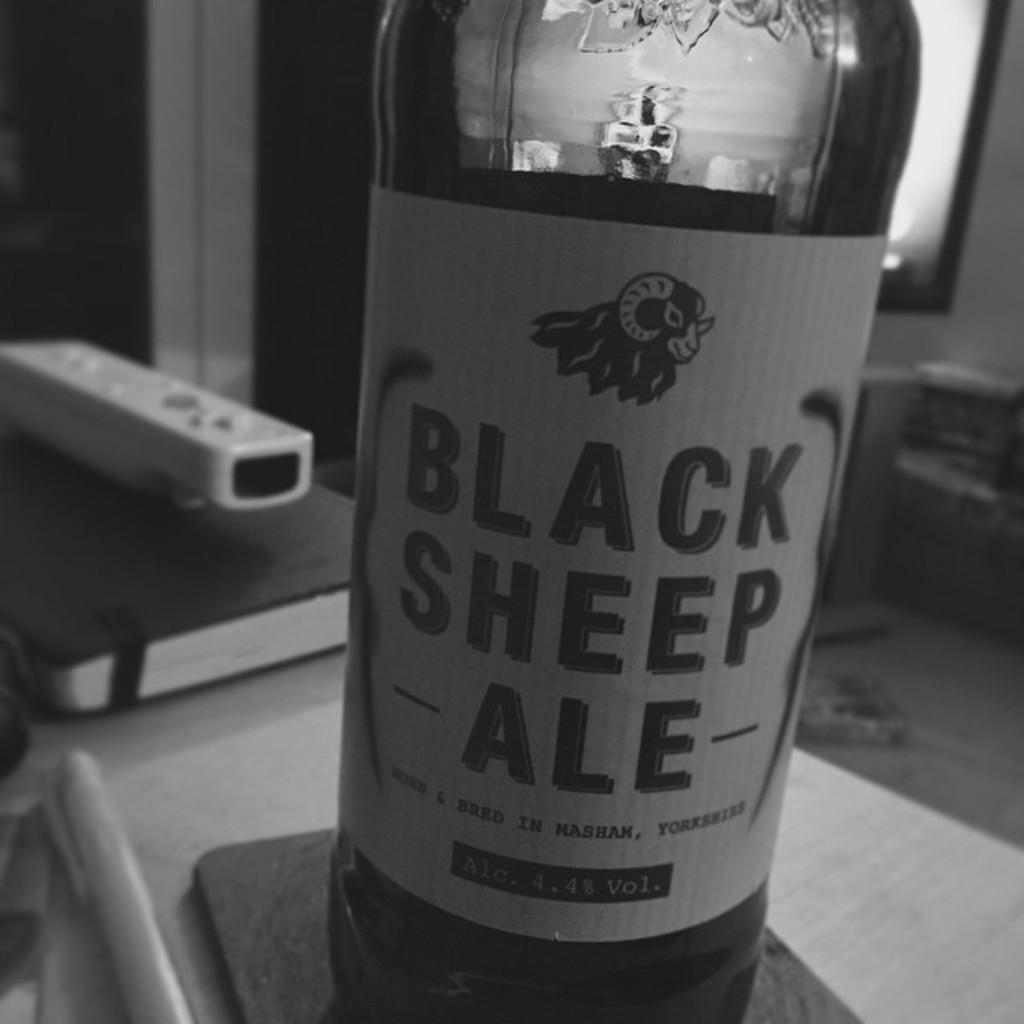Provide a one-sentence caption for the provided image. A bottle of Black Sheep ale sitting on a coaster. 